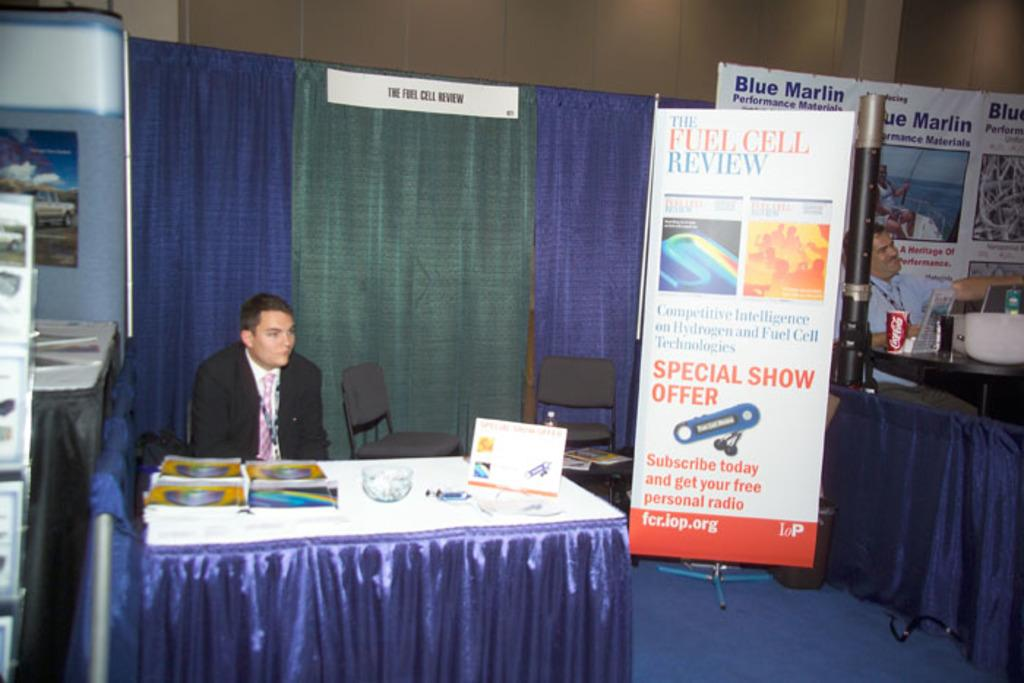<image>
Relay a brief, clear account of the picture shown. a man sitting next to a special show offer sign 